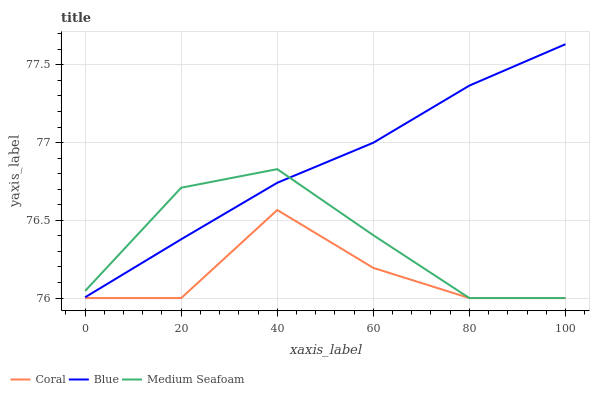Does Medium Seafoam have the minimum area under the curve?
Answer yes or no. No. Does Medium Seafoam have the maximum area under the curve?
Answer yes or no. No. Is Medium Seafoam the smoothest?
Answer yes or no. No. Is Medium Seafoam the roughest?
Answer yes or no. No. Does Medium Seafoam have the highest value?
Answer yes or no. No. Is Coral less than Blue?
Answer yes or no. Yes. Is Blue greater than Coral?
Answer yes or no. Yes. Does Coral intersect Blue?
Answer yes or no. No. 